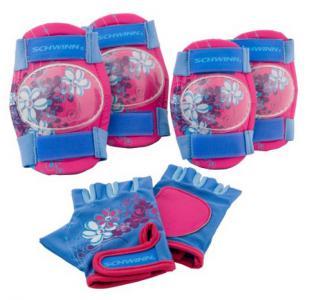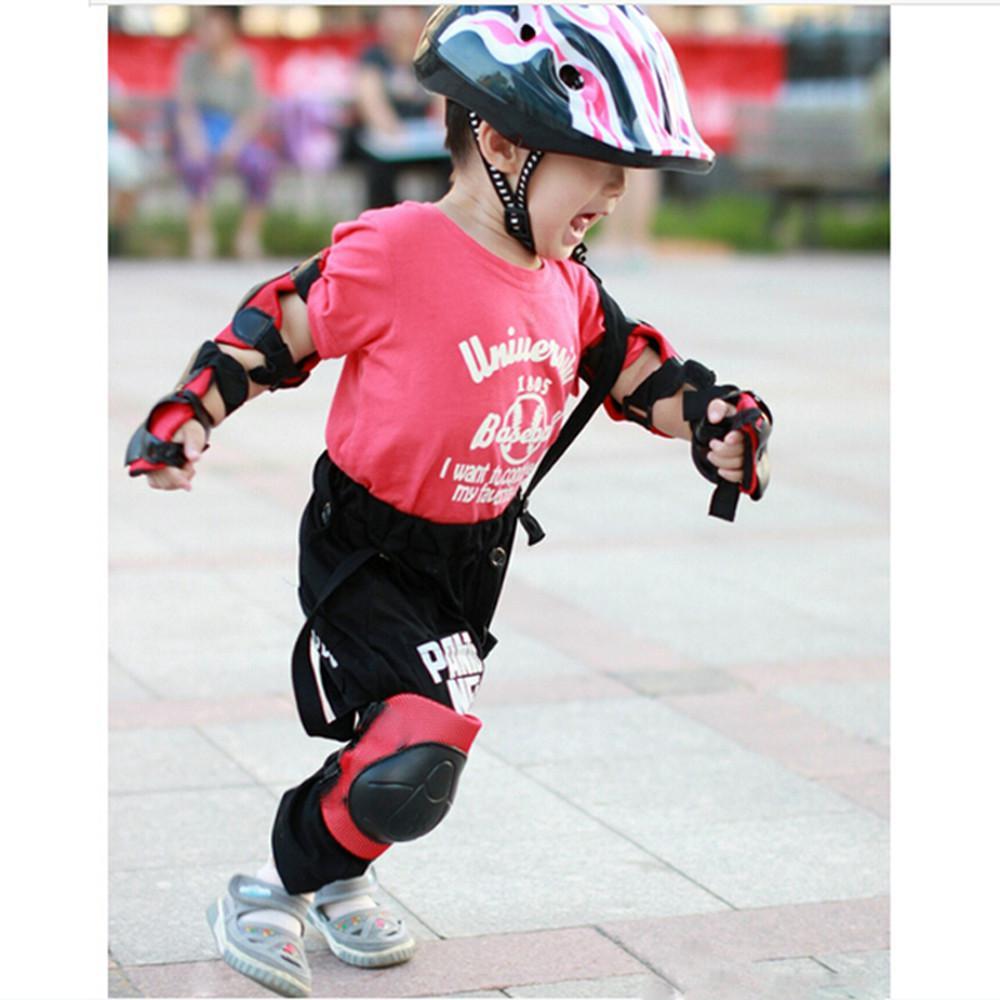The first image is the image on the left, the second image is the image on the right. Considering the images on both sides, is "The image on the left has kneepads with only neutral colors such as black and white on it." valid? Answer yes or no. No. The first image is the image on the left, the second image is the image on the right. Evaluate the accuracy of this statement regarding the images: "An image includes fingerless gloves and two pairs of pads.". Is it true? Answer yes or no. Yes. 